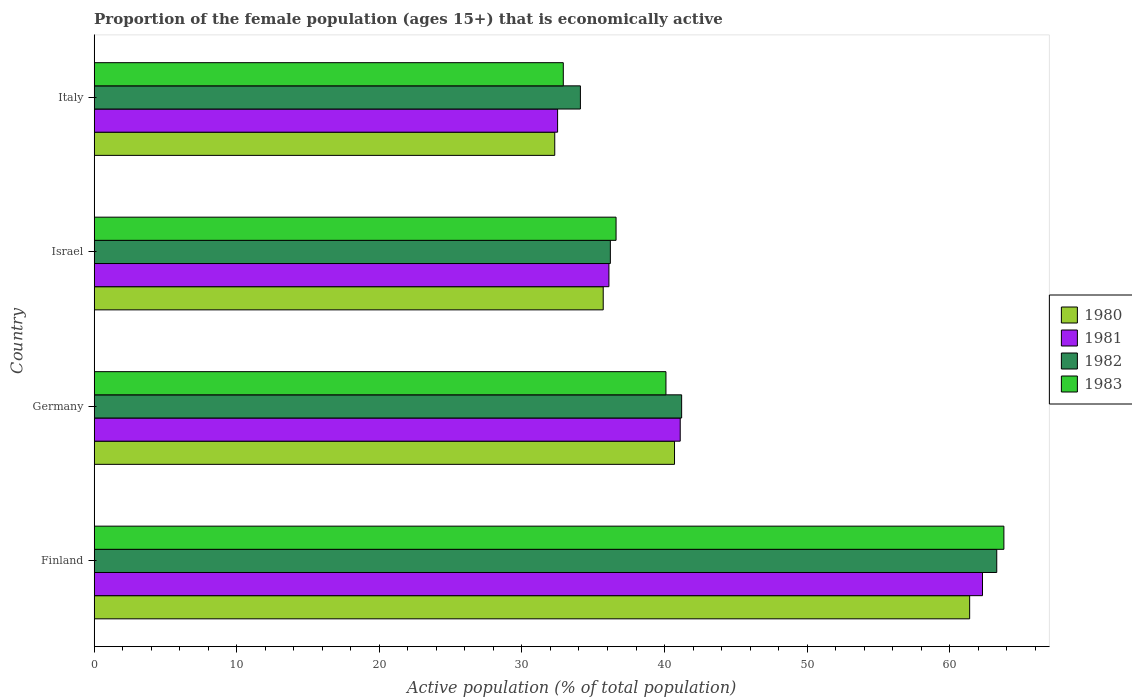How many different coloured bars are there?
Your response must be concise. 4. How many groups of bars are there?
Offer a terse response. 4. Are the number of bars per tick equal to the number of legend labels?
Provide a succinct answer. Yes. What is the proportion of the female population that is economically active in 1981 in Israel?
Offer a terse response. 36.1. Across all countries, what is the maximum proportion of the female population that is economically active in 1982?
Provide a short and direct response. 63.3. Across all countries, what is the minimum proportion of the female population that is economically active in 1980?
Offer a very short reply. 32.3. What is the total proportion of the female population that is economically active in 1980 in the graph?
Provide a short and direct response. 170.1. What is the difference between the proportion of the female population that is economically active in 1983 in Finland and that in Italy?
Offer a very short reply. 30.9. What is the difference between the proportion of the female population that is economically active in 1981 in Germany and the proportion of the female population that is economically active in 1980 in Finland?
Offer a terse response. -20.3. What is the average proportion of the female population that is economically active in 1980 per country?
Provide a short and direct response. 42.53. What is the ratio of the proportion of the female population that is economically active in 1980 in Finland to that in Italy?
Provide a short and direct response. 1.9. Is the proportion of the female population that is economically active in 1983 in Germany less than that in Italy?
Provide a succinct answer. No. What is the difference between the highest and the second highest proportion of the female population that is economically active in 1983?
Ensure brevity in your answer.  23.7. What is the difference between the highest and the lowest proportion of the female population that is economically active in 1983?
Make the answer very short. 30.9. In how many countries, is the proportion of the female population that is economically active in 1983 greater than the average proportion of the female population that is economically active in 1983 taken over all countries?
Keep it short and to the point. 1. Is the sum of the proportion of the female population that is economically active in 1980 in Finland and Israel greater than the maximum proportion of the female population that is economically active in 1981 across all countries?
Offer a very short reply. Yes. Is it the case that in every country, the sum of the proportion of the female population that is economically active in 1983 and proportion of the female population that is economically active in 1980 is greater than the sum of proportion of the female population that is economically active in 1982 and proportion of the female population that is economically active in 1981?
Your answer should be compact. No. What does the 1st bar from the top in Italy represents?
Provide a short and direct response. 1983. What is the difference between two consecutive major ticks on the X-axis?
Give a very brief answer. 10. Does the graph contain any zero values?
Your response must be concise. No. Where does the legend appear in the graph?
Provide a short and direct response. Center right. What is the title of the graph?
Your answer should be very brief. Proportion of the female population (ages 15+) that is economically active. What is the label or title of the X-axis?
Offer a terse response. Active population (% of total population). What is the Active population (% of total population) in 1980 in Finland?
Your response must be concise. 61.4. What is the Active population (% of total population) of 1981 in Finland?
Offer a terse response. 62.3. What is the Active population (% of total population) in 1982 in Finland?
Your answer should be compact. 63.3. What is the Active population (% of total population) of 1983 in Finland?
Your answer should be compact. 63.8. What is the Active population (% of total population) in 1980 in Germany?
Your response must be concise. 40.7. What is the Active population (% of total population) of 1981 in Germany?
Give a very brief answer. 41.1. What is the Active population (% of total population) of 1982 in Germany?
Keep it short and to the point. 41.2. What is the Active population (% of total population) of 1983 in Germany?
Make the answer very short. 40.1. What is the Active population (% of total population) of 1980 in Israel?
Provide a short and direct response. 35.7. What is the Active population (% of total population) in 1981 in Israel?
Provide a succinct answer. 36.1. What is the Active population (% of total population) in 1982 in Israel?
Offer a terse response. 36.2. What is the Active population (% of total population) in 1983 in Israel?
Offer a terse response. 36.6. What is the Active population (% of total population) in 1980 in Italy?
Offer a terse response. 32.3. What is the Active population (% of total population) of 1981 in Italy?
Ensure brevity in your answer.  32.5. What is the Active population (% of total population) of 1982 in Italy?
Keep it short and to the point. 34.1. What is the Active population (% of total population) in 1983 in Italy?
Offer a very short reply. 32.9. Across all countries, what is the maximum Active population (% of total population) of 1980?
Keep it short and to the point. 61.4. Across all countries, what is the maximum Active population (% of total population) of 1981?
Give a very brief answer. 62.3. Across all countries, what is the maximum Active population (% of total population) of 1982?
Offer a terse response. 63.3. Across all countries, what is the maximum Active population (% of total population) in 1983?
Your response must be concise. 63.8. Across all countries, what is the minimum Active population (% of total population) in 1980?
Make the answer very short. 32.3. Across all countries, what is the minimum Active population (% of total population) of 1981?
Keep it short and to the point. 32.5. Across all countries, what is the minimum Active population (% of total population) of 1982?
Make the answer very short. 34.1. Across all countries, what is the minimum Active population (% of total population) in 1983?
Your answer should be very brief. 32.9. What is the total Active population (% of total population) in 1980 in the graph?
Your response must be concise. 170.1. What is the total Active population (% of total population) in 1981 in the graph?
Your answer should be compact. 172. What is the total Active population (% of total population) in 1982 in the graph?
Offer a very short reply. 174.8. What is the total Active population (% of total population) of 1983 in the graph?
Make the answer very short. 173.4. What is the difference between the Active population (% of total population) in 1980 in Finland and that in Germany?
Offer a terse response. 20.7. What is the difference between the Active population (% of total population) in 1981 in Finland and that in Germany?
Your answer should be very brief. 21.2. What is the difference between the Active population (% of total population) of 1982 in Finland and that in Germany?
Keep it short and to the point. 22.1. What is the difference between the Active population (% of total population) of 1983 in Finland and that in Germany?
Offer a very short reply. 23.7. What is the difference between the Active population (% of total population) of 1980 in Finland and that in Israel?
Offer a very short reply. 25.7. What is the difference between the Active population (% of total population) of 1981 in Finland and that in Israel?
Your answer should be compact. 26.2. What is the difference between the Active population (% of total population) in 1982 in Finland and that in Israel?
Offer a terse response. 27.1. What is the difference between the Active population (% of total population) of 1983 in Finland and that in Israel?
Your answer should be compact. 27.2. What is the difference between the Active population (% of total population) in 1980 in Finland and that in Italy?
Provide a succinct answer. 29.1. What is the difference between the Active population (% of total population) in 1981 in Finland and that in Italy?
Offer a very short reply. 29.8. What is the difference between the Active population (% of total population) of 1982 in Finland and that in Italy?
Make the answer very short. 29.2. What is the difference between the Active population (% of total population) in 1983 in Finland and that in Italy?
Provide a succinct answer. 30.9. What is the difference between the Active population (% of total population) of 1982 in Germany and that in Israel?
Your answer should be very brief. 5. What is the difference between the Active population (% of total population) of 1983 in Germany and that in Israel?
Provide a succinct answer. 3.5. What is the difference between the Active population (% of total population) in 1980 in Germany and that in Italy?
Make the answer very short. 8.4. What is the difference between the Active population (% of total population) in 1981 in Germany and that in Italy?
Offer a terse response. 8.6. What is the difference between the Active population (% of total population) of 1982 in Israel and that in Italy?
Provide a succinct answer. 2.1. What is the difference between the Active population (% of total population) in 1983 in Israel and that in Italy?
Provide a succinct answer. 3.7. What is the difference between the Active population (% of total population) of 1980 in Finland and the Active population (% of total population) of 1981 in Germany?
Give a very brief answer. 20.3. What is the difference between the Active population (% of total population) in 1980 in Finland and the Active population (% of total population) in 1982 in Germany?
Give a very brief answer. 20.2. What is the difference between the Active population (% of total population) of 1980 in Finland and the Active population (% of total population) of 1983 in Germany?
Provide a short and direct response. 21.3. What is the difference between the Active population (% of total population) of 1981 in Finland and the Active population (% of total population) of 1982 in Germany?
Ensure brevity in your answer.  21.1. What is the difference between the Active population (% of total population) of 1981 in Finland and the Active population (% of total population) of 1983 in Germany?
Keep it short and to the point. 22.2. What is the difference between the Active population (% of total population) of 1982 in Finland and the Active population (% of total population) of 1983 in Germany?
Give a very brief answer. 23.2. What is the difference between the Active population (% of total population) of 1980 in Finland and the Active population (% of total population) of 1981 in Israel?
Keep it short and to the point. 25.3. What is the difference between the Active population (% of total population) in 1980 in Finland and the Active population (% of total population) in 1982 in Israel?
Keep it short and to the point. 25.2. What is the difference between the Active population (% of total population) in 1980 in Finland and the Active population (% of total population) in 1983 in Israel?
Make the answer very short. 24.8. What is the difference between the Active population (% of total population) in 1981 in Finland and the Active population (% of total population) in 1982 in Israel?
Keep it short and to the point. 26.1. What is the difference between the Active population (% of total population) in 1981 in Finland and the Active population (% of total population) in 1983 in Israel?
Keep it short and to the point. 25.7. What is the difference between the Active population (% of total population) in 1982 in Finland and the Active population (% of total population) in 1983 in Israel?
Your answer should be very brief. 26.7. What is the difference between the Active population (% of total population) in 1980 in Finland and the Active population (% of total population) in 1981 in Italy?
Provide a succinct answer. 28.9. What is the difference between the Active population (% of total population) in 1980 in Finland and the Active population (% of total population) in 1982 in Italy?
Provide a succinct answer. 27.3. What is the difference between the Active population (% of total population) of 1980 in Finland and the Active population (% of total population) of 1983 in Italy?
Offer a terse response. 28.5. What is the difference between the Active population (% of total population) of 1981 in Finland and the Active population (% of total population) of 1982 in Italy?
Make the answer very short. 28.2. What is the difference between the Active population (% of total population) in 1981 in Finland and the Active population (% of total population) in 1983 in Italy?
Give a very brief answer. 29.4. What is the difference between the Active population (% of total population) in 1982 in Finland and the Active population (% of total population) in 1983 in Italy?
Ensure brevity in your answer.  30.4. What is the difference between the Active population (% of total population) in 1980 in Germany and the Active population (% of total population) in 1982 in Israel?
Give a very brief answer. 4.5. What is the difference between the Active population (% of total population) of 1982 in Germany and the Active population (% of total population) of 1983 in Israel?
Ensure brevity in your answer.  4.6. What is the difference between the Active population (% of total population) of 1981 in Israel and the Active population (% of total population) of 1983 in Italy?
Ensure brevity in your answer.  3.2. What is the difference between the Active population (% of total population) in 1982 in Israel and the Active population (% of total population) in 1983 in Italy?
Your answer should be compact. 3.3. What is the average Active population (% of total population) in 1980 per country?
Keep it short and to the point. 42.52. What is the average Active population (% of total population) in 1981 per country?
Ensure brevity in your answer.  43. What is the average Active population (% of total population) in 1982 per country?
Ensure brevity in your answer.  43.7. What is the average Active population (% of total population) in 1983 per country?
Your response must be concise. 43.35. What is the difference between the Active population (% of total population) in 1980 and Active population (% of total population) in 1983 in Finland?
Your answer should be very brief. -2.4. What is the difference between the Active population (% of total population) in 1981 and Active population (% of total population) in 1983 in Finland?
Ensure brevity in your answer.  -1.5. What is the difference between the Active population (% of total population) in 1982 and Active population (% of total population) in 1983 in Finland?
Give a very brief answer. -0.5. What is the difference between the Active population (% of total population) of 1980 and Active population (% of total population) of 1982 in Germany?
Offer a terse response. -0.5. What is the difference between the Active population (% of total population) of 1981 and Active population (% of total population) of 1982 in Germany?
Your response must be concise. -0.1. What is the difference between the Active population (% of total population) of 1981 and Active population (% of total population) of 1983 in Germany?
Ensure brevity in your answer.  1. What is the difference between the Active population (% of total population) of 1980 and Active population (% of total population) of 1982 in Israel?
Your response must be concise. -0.5. What is the difference between the Active population (% of total population) in 1981 and Active population (% of total population) in 1983 in Israel?
Make the answer very short. -0.5. What is the difference between the Active population (% of total population) in 1982 and Active population (% of total population) in 1983 in Israel?
Offer a terse response. -0.4. What is the difference between the Active population (% of total population) of 1980 and Active population (% of total population) of 1982 in Italy?
Provide a short and direct response. -1.8. What is the difference between the Active population (% of total population) in 1981 and Active population (% of total population) in 1983 in Italy?
Your response must be concise. -0.4. What is the ratio of the Active population (% of total population) in 1980 in Finland to that in Germany?
Ensure brevity in your answer.  1.51. What is the ratio of the Active population (% of total population) of 1981 in Finland to that in Germany?
Keep it short and to the point. 1.52. What is the ratio of the Active population (% of total population) in 1982 in Finland to that in Germany?
Ensure brevity in your answer.  1.54. What is the ratio of the Active population (% of total population) of 1983 in Finland to that in Germany?
Offer a very short reply. 1.59. What is the ratio of the Active population (% of total population) in 1980 in Finland to that in Israel?
Your response must be concise. 1.72. What is the ratio of the Active population (% of total population) in 1981 in Finland to that in Israel?
Offer a terse response. 1.73. What is the ratio of the Active population (% of total population) of 1982 in Finland to that in Israel?
Offer a very short reply. 1.75. What is the ratio of the Active population (% of total population) of 1983 in Finland to that in Israel?
Keep it short and to the point. 1.74. What is the ratio of the Active population (% of total population) of 1980 in Finland to that in Italy?
Ensure brevity in your answer.  1.9. What is the ratio of the Active population (% of total population) of 1981 in Finland to that in Italy?
Your response must be concise. 1.92. What is the ratio of the Active population (% of total population) in 1982 in Finland to that in Italy?
Provide a short and direct response. 1.86. What is the ratio of the Active population (% of total population) of 1983 in Finland to that in Italy?
Make the answer very short. 1.94. What is the ratio of the Active population (% of total population) in 1980 in Germany to that in Israel?
Provide a succinct answer. 1.14. What is the ratio of the Active population (% of total population) in 1981 in Germany to that in Israel?
Your answer should be very brief. 1.14. What is the ratio of the Active population (% of total population) of 1982 in Germany to that in Israel?
Keep it short and to the point. 1.14. What is the ratio of the Active population (% of total population) of 1983 in Germany to that in Israel?
Keep it short and to the point. 1.1. What is the ratio of the Active population (% of total population) in 1980 in Germany to that in Italy?
Provide a succinct answer. 1.26. What is the ratio of the Active population (% of total population) in 1981 in Germany to that in Italy?
Make the answer very short. 1.26. What is the ratio of the Active population (% of total population) of 1982 in Germany to that in Italy?
Offer a terse response. 1.21. What is the ratio of the Active population (% of total population) of 1983 in Germany to that in Italy?
Provide a short and direct response. 1.22. What is the ratio of the Active population (% of total population) in 1980 in Israel to that in Italy?
Your response must be concise. 1.11. What is the ratio of the Active population (% of total population) of 1981 in Israel to that in Italy?
Offer a very short reply. 1.11. What is the ratio of the Active population (% of total population) in 1982 in Israel to that in Italy?
Offer a terse response. 1.06. What is the ratio of the Active population (% of total population) in 1983 in Israel to that in Italy?
Offer a terse response. 1.11. What is the difference between the highest and the second highest Active population (% of total population) of 1980?
Your answer should be compact. 20.7. What is the difference between the highest and the second highest Active population (% of total population) in 1981?
Offer a very short reply. 21.2. What is the difference between the highest and the second highest Active population (% of total population) in 1982?
Keep it short and to the point. 22.1. What is the difference between the highest and the second highest Active population (% of total population) of 1983?
Ensure brevity in your answer.  23.7. What is the difference between the highest and the lowest Active population (% of total population) in 1980?
Your answer should be very brief. 29.1. What is the difference between the highest and the lowest Active population (% of total population) of 1981?
Keep it short and to the point. 29.8. What is the difference between the highest and the lowest Active population (% of total population) in 1982?
Offer a very short reply. 29.2. What is the difference between the highest and the lowest Active population (% of total population) of 1983?
Provide a short and direct response. 30.9. 